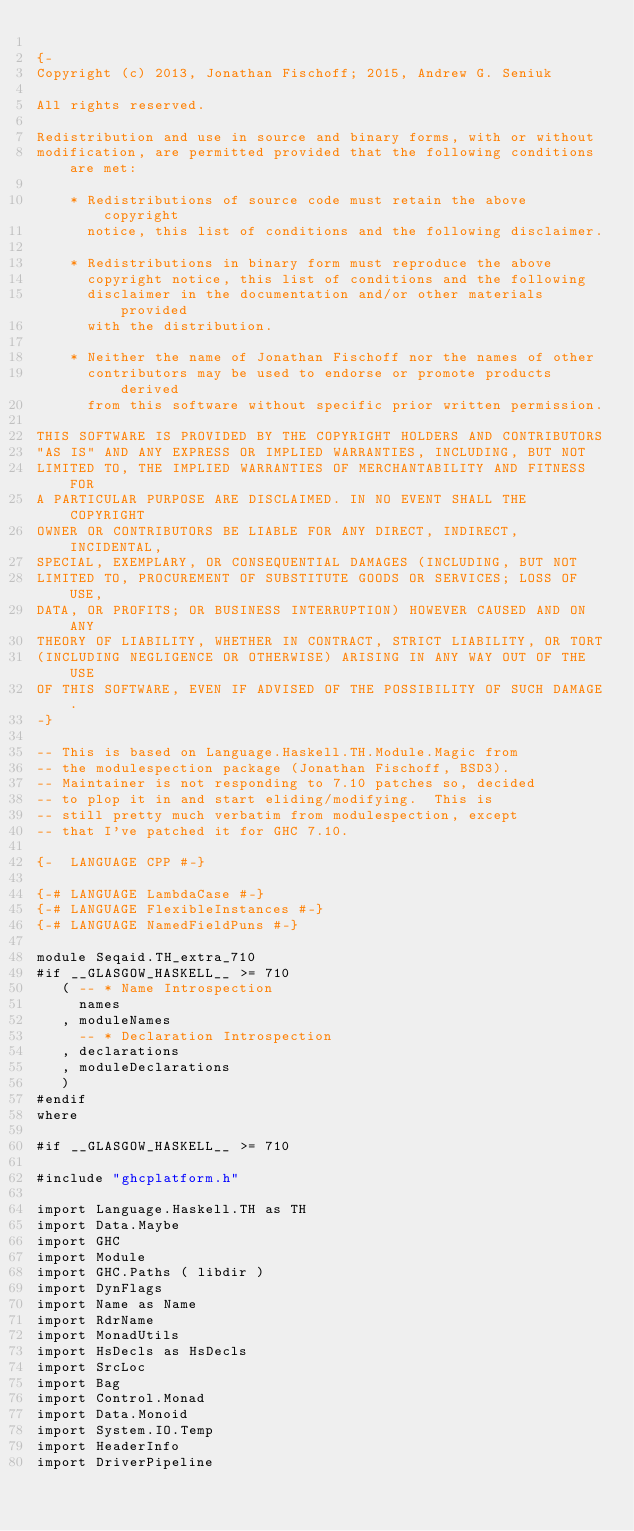Convert code to text. <code><loc_0><loc_0><loc_500><loc_500><_Haskell_>
{-
Copyright (c) 2013, Jonathan Fischoff; 2015, Andrew G. Seniuk

All rights reserved.

Redistribution and use in source and binary forms, with or without
modification, are permitted provided that the following conditions are met:

    * Redistributions of source code must retain the above copyright
      notice, this list of conditions and the following disclaimer.

    * Redistributions in binary form must reproduce the above
      copyright notice, this list of conditions and the following
      disclaimer in the documentation and/or other materials provided
      with the distribution.

    * Neither the name of Jonathan Fischoff nor the names of other
      contributors may be used to endorse or promote products derived
      from this software without specific prior written permission.

THIS SOFTWARE IS PROVIDED BY THE COPYRIGHT HOLDERS AND CONTRIBUTORS
"AS IS" AND ANY EXPRESS OR IMPLIED WARRANTIES, INCLUDING, BUT NOT
LIMITED TO, THE IMPLIED WARRANTIES OF MERCHANTABILITY AND FITNESS FOR
A PARTICULAR PURPOSE ARE DISCLAIMED. IN NO EVENT SHALL THE COPYRIGHT
OWNER OR CONTRIBUTORS BE LIABLE FOR ANY DIRECT, INDIRECT, INCIDENTAL,
SPECIAL, EXEMPLARY, OR CONSEQUENTIAL DAMAGES (INCLUDING, BUT NOT
LIMITED TO, PROCUREMENT OF SUBSTITUTE GOODS OR SERVICES; LOSS OF USE,
DATA, OR PROFITS; OR BUSINESS INTERRUPTION) HOWEVER CAUSED AND ON ANY
THEORY OF LIABILITY, WHETHER IN CONTRACT, STRICT LIABILITY, OR TORT
(INCLUDING NEGLIGENCE OR OTHERWISE) ARISING IN ANY WAY OUT OF THE USE
OF THIS SOFTWARE, EVEN IF ADVISED OF THE POSSIBILITY OF SUCH DAMAGE.
-}

-- This is based on Language.Haskell.TH.Module.Magic from
-- the modulespection package (Jonathan Fischoff, BSD3).
-- Maintainer is not responding to 7.10 patches so, decided
-- to plop it in and start eliding/modifying.  This is
-- still pretty much verbatim from modulespection, except
-- that I've patched it for GHC 7.10.

{-  LANGUAGE CPP #-}

{-# LANGUAGE LambdaCase #-}
{-# LANGUAGE FlexibleInstances #-}
{-# LANGUAGE NamedFieldPuns #-}

module Seqaid.TH_extra_710
#if __GLASGOW_HASKELL__ >= 710
   ( -- * Name Introspection
     names
   , moduleNames
     -- * Declaration Introspection
   , declarations
   , moduleDeclarations
   )
#endif
where

#if __GLASGOW_HASKELL__ >= 710

#include "ghcplatform.h"
   
import Language.Haskell.TH as TH
import Data.Maybe
import GHC
import Module
import GHC.Paths ( libdir )
import DynFlags 
import Name as Name
import RdrName 
import MonadUtils
import HsDecls as HsDecls
import SrcLoc
import Bag
import Control.Monad
import Data.Monoid
import System.IO.Temp
import HeaderInfo
import DriverPipeline</code> 